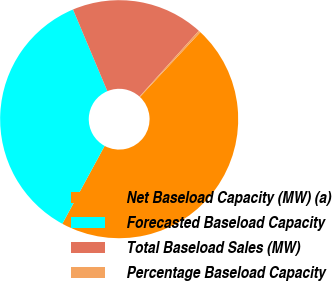Convert chart to OTSL. <chart><loc_0><loc_0><loc_500><loc_500><pie_chart><fcel>Net Baseload Capacity (MW) (a)<fcel>Forecasted Baseload Capacity<fcel>Total Baseload Sales (MW)<fcel>Percentage Baseload Capacity<nl><fcel>45.98%<fcel>35.74%<fcel>18.01%<fcel>0.27%<nl></chart> 